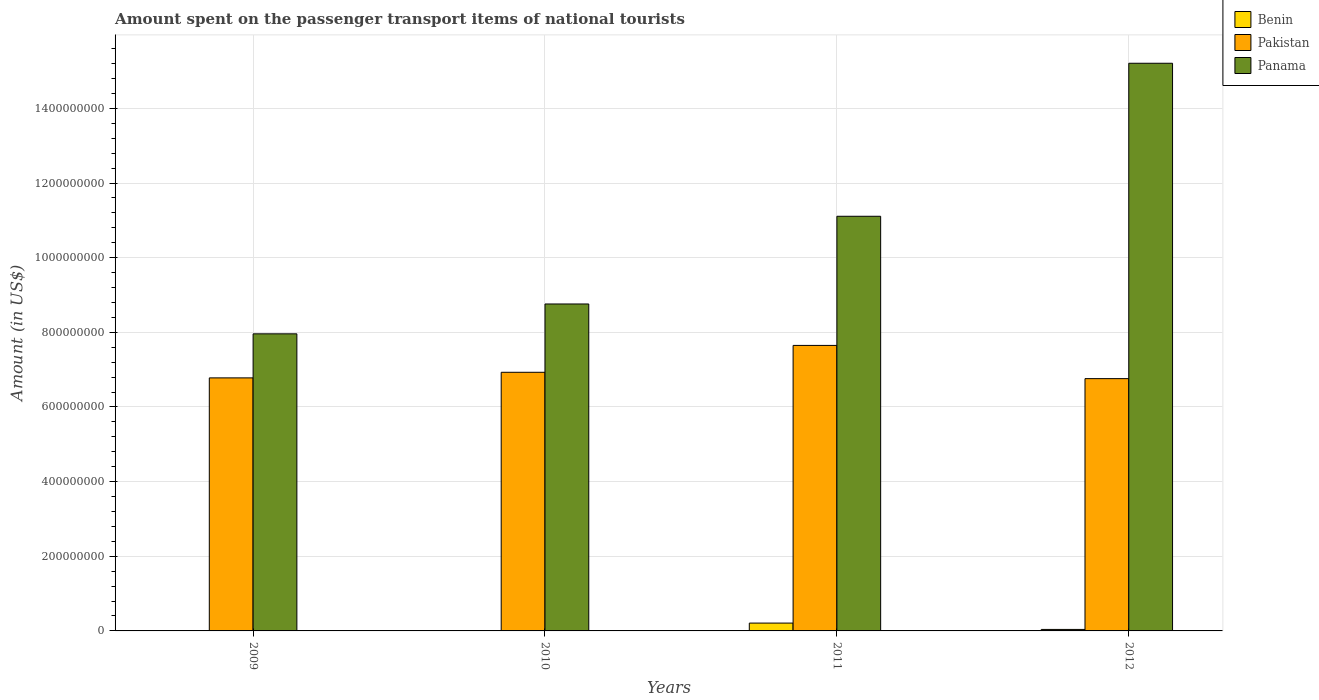How many groups of bars are there?
Ensure brevity in your answer.  4. Are the number of bars per tick equal to the number of legend labels?
Offer a terse response. Yes. Are the number of bars on each tick of the X-axis equal?
Your answer should be compact. Yes. How many bars are there on the 1st tick from the left?
Ensure brevity in your answer.  3. What is the amount spent on the passenger transport items of national tourists in Benin in 2010?
Ensure brevity in your answer.  4.00e+05. Across all years, what is the maximum amount spent on the passenger transport items of national tourists in Benin?
Your answer should be compact. 2.10e+07. Across all years, what is the minimum amount spent on the passenger transport items of national tourists in Benin?
Offer a very short reply. 4.00e+05. In which year was the amount spent on the passenger transport items of national tourists in Benin maximum?
Offer a terse response. 2011. What is the total amount spent on the passenger transport items of national tourists in Panama in the graph?
Give a very brief answer. 4.30e+09. What is the difference between the amount spent on the passenger transport items of national tourists in Panama in 2010 and that in 2011?
Make the answer very short. -2.35e+08. What is the difference between the amount spent on the passenger transport items of national tourists in Pakistan in 2011 and the amount spent on the passenger transport items of national tourists in Panama in 2012?
Keep it short and to the point. -7.56e+08. What is the average amount spent on the passenger transport items of national tourists in Panama per year?
Provide a short and direct response. 1.08e+09. In the year 2009, what is the difference between the amount spent on the passenger transport items of national tourists in Benin and amount spent on the passenger transport items of national tourists in Panama?
Ensure brevity in your answer.  -7.96e+08. In how many years, is the amount spent on the passenger transport items of national tourists in Benin greater than 560000000 US$?
Provide a succinct answer. 0. What is the ratio of the amount spent on the passenger transport items of national tourists in Pakistan in 2010 to that in 2011?
Give a very brief answer. 0.91. Is the amount spent on the passenger transport items of national tourists in Benin in 2009 less than that in 2012?
Your response must be concise. Yes. Is the difference between the amount spent on the passenger transport items of national tourists in Benin in 2010 and 2012 greater than the difference between the amount spent on the passenger transport items of national tourists in Panama in 2010 and 2012?
Give a very brief answer. Yes. What is the difference between the highest and the second highest amount spent on the passenger transport items of national tourists in Pakistan?
Your answer should be very brief. 7.20e+07. What is the difference between the highest and the lowest amount spent on the passenger transport items of national tourists in Panama?
Keep it short and to the point. 7.25e+08. In how many years, is the amount spent on the passenger transport items of national tourists in Benin greater than the average amount spent on the passenger transport items of national tourists in Benin taken over all years?
Give a very brief answer. 1. What does the 1st bar from the left in 2011 represents?
Give a very brief answer. Benin. What does the 2nd bar from the right in 2012 represents?
Keep it short and to the point. Pakistan. How many bars are there?
Your answer should be compact. 12. How many years are there in the graph?
Provide a succinct answer. 4. Does the graph contain any zero values?
Provide a short and direct response. No. Where does the legend appear in the graph?
Your answer should be compact. Top right. What is the title of the graph?
Make the answer very short. Amount spent on the passenger transport items of national tourists. What is the Amount (in US$) of Pakistan in 2009?
Your answer should be very brief. 6.78e+08. What is the Amount (in US$) of Panama in 2009?
Keep it short and to the point. 7.96e+08. What is the Amount (in US$) of Pakistan in 2010?
Provide a succinct answer. 6.93e+08. What is the Amount (in US$) of Panama in 2010?
Provide a succinct answer. 8.76e+08. What is the Amount (in US$) of Benin in 2011?
Your answer should be very brief. 2.10e+07. What is the Amount (in US$) in Pakistan in 2011?
Offer a very short reply. 7.65e+08. What is the Amount (in US$) in Panama in 2011?
Your response must be concise. 1.11e+09. What is the Amount (in US$) in Pakistan in 2012?
Your answer should be very brief. 6.76e+08. What is the Amount (in US$) in Panama in 2012?
Offer a terse response. 1.52e+09. Across all years, what is the maximum Amount (in US$) in Benin?
Give a very brief answer. 2.10e+07. Across all years, what is the maximum Amount (in US$) in Pakistan?
Keep it short and to the point. 7.65e+08. Across all years, what is the maximum Amount (in US$) of Panama?
Provide a succinct answer. 1.52e+09. Across all years, what is the minimum Amount (in US$) in Benin?
Keep it short and to the point. 4.00e+05. Across all years, what is the minimum Amount (in US$) of Pakistan?
Your answer should be very brief. 6.76e+08. Across all years, what is the minimum Amount (in US$) of Panama?
Your answer should be compact. 7.96e+08. What is the total Amount (in US$) of Benin in the graph?
Make the answer very short. 2.58e+07. What is the total Amount (in US$) of Pakistan in the graph?
Offer a very short reply. 2.81e+09. What is the total Amount (in US$) in Panama in the graph?
Provide a succinct answer. 4.30e+09. What is the difference between the Amount (in US$) in Pakistan in 2009 and that in 2010?
Ensure brevity in your answer.  -1.50e+07. What is the difference between the Amount (in US$) in Panama in 2009 and that in 2010?
Give a very brief answer. -8.00e+07. What is the difference between the Amount (in US$) of Benin in 2009 and that in 2011?
Keep it short and to the point. -2.06e+07. What is the difference between the Amount (in US$) of Pakistan in 2009 and that in 2011?
Keep it short and to the point. -8.70e+07. What is the difference between the Amount (in US$) of Panama in 2009 and that in 2011?
Provide a succinct answer. -3.15e+08. What is the difference between the Amount (in US$) in Benin in 2009 and that in 2012?
Provide a succinct answer. -3.60e+06. What is the difference between the Amount (in US$) of Pakistan in 2009 and that in 2012?
Your answer should be compact. 2.00e+06. What is the difference between the Amount (in US$) in Panama in 2009 and that in 2012?
Provide a succinct answer. -7.25e+08. What is the difference between the Amount (in US$) in Benin in 2010 and that in 2011?
Your answer should be compact. -2.06e+07. What is the difference between the Amount (in US$) of Pakistan in 2010 and that in 2011?
Make the answer very short. -7.20e+07. What is the difference between the Amount (in US$) of Panama in 2010 and that in 2011?
Offer a terse response. -2.35e+08. What is the difference between the Amount (in US$) in Benin in 2010 and that in 2012?
Give a very brief answer. -3.60e+06. What is the difference between the Amount (in US$) of Pakistan in 2010 and that in 2012?
Provide a short and direct response. 1.70e+07. What is the difference between the Amount (in US$) in Panama in 2010 and that in 2012?
Your answer should be compact. -6.45e+08. What is the difference between the Amount (in US$) in Benin in 2011 and that in 2012?
Your response must be concise. 1.70e+07. What is the difference between the Amount (in US$) in Pakistan in 2011 and that in 2012?
Offer a terse response. 8.90e+07. What is the difference between the Amount (in US$) of Panama in 2011 and that in 2012?
Ensure brevity in your answer.  -4.10e+08. What is the difference between the Amount (in US$) of Benin in 2009 and the Amount (in US$) of Pakistan in 2010?
Ensure brevity in your answer.  -6.93e+08. What is the difference between the Amount (in US$) in Benin in 2009 and the Amount (in US$) in Panama in 2010?
Keep it short and to the point. -8.76e+08. What is the difference between the Amount (in US$) in Pakistan in 2009 and the Amount (in US$) in Panama in 2010?
Provide a succinct answer. -1.98e+08. What is the difference between the Amount (in US$) in Benin in 2009 and the Amount (in US$) in Pakistan in 2011?
Provide a short and direct response. -7.65e+08. What is the difference between the Amount (in US$) of Benin in 2009 and the Amount (in US$) of Panama in 2011?
Provide a succinct answer. -1.11e+09. What is the difference between the Amount (in US$) of Pakistan in 2009 and the Amount (in US$) of Panama in 2011?
Your response must be concise. -4.33e+08. What is the difference between the Amount (in US$) in Benin in 2009 and the Amount (in US$) in Pakistan in 2012?
Offer a very short reply. -6.76e+08. What is the difference between the Amount (in US$) in Benin in 2009 and the Amount (in US$) in Panama in 2012?
Provide a succinct answer. -1.52e+09. What is the difference between the Amount (in US$) of Pakistan in 2009 and the Amount (in US$) of Panama in 2012?
Your answer should be compact. -8.43e+08. What is the difference between the Amount (in US$) in Benin in 2010 and the Amount (in US$) in Pakistan in 2011?
Your answer should be very brief. -7.65e+08. What is the difference between the Amount (in US$) of Benin in 2010 and the Amount (in US$) of Panama in 2011?
Your response must be concise. -1.11e+09. What is the difference between the Amount (in US$) in Pakistan in 2010 and the Amount (in US$) in Panama in 2011?
Keep it short and to the point. -4.18e+08. What is the difference between the Amount (in US$) of Benin in 2010 and the Amount (in US$) of Pakistan in 2012?
Offer a terse response. -6.76e+08. What is the difference between the Amount (in US$) in Benin in 2010 and the Amount (in US$) in Panama in 2012?
Keep it short and to the point. -1.52e+09. What is the difference between the Amount (in US$) in Pakistan in 2010 and the Amount (in US$) in Panama in 2012?
Give a very brief answer. -8.28e+08. What is the difference between the Amount (in US$) in Benin in 2011 and the Amount (in US$) in Pakistan in 2012?
Make the answer very short. -6.55e+08. What is the difference between the Amount (in US$) of Benin in 2011 and the Amount (in US$) of Panama in 2012?
Ensure brevity in your answer.  -1.50e+09. What is the difference between the Amount (in US$) in Pakistan in 2011 and the Amount (in US$) in Panama in 2012?
Keep it short and to the point. -7.56e+08. What is the average Amount (in US$) in Benin per year?
Give a very brief answer. 6.45e+06. What is the average Amount (in US$) of Pakistan per year?
Keep it short and to the point. 7.03e+08. What is the average Amount (in US$) of Panama per year?
Make the answer very short. 1.08e+09. In the year 2009, what is the difference between the Amount (in US$) of Benin and Amount (in US$) of Pakistan?
Provide a succinct answer. -6.78e+08. In the year 2009, what is the difference between the Amount (in US$) in Benin and Amount (in US$) in Panama?
Make the answer very short. -7.96e+08. In the year 2009, what is the difference between the Amount (in US$) in Pakistan and Amount (in US$) in Panama?
Make the answer very short. -1.18e+08. In the year 2010, what is the difference between the Amount (in US$) of Benin and Amount (in US$) of Pakistan?
Keep it short and to the point. -6.93e+08. In the year 2010, what is the difference between the Amount (in US$) of Benin and Amount (in US$) of Panama?
Your answer should be compact. -8.76e+08. In the year 2010, what is the difference between the Amount (in US$) in Pakistan and Amount (in US$) in Panama?
Give a very brief answer. -1.83e+08. In the year 2011, what is the difference between the Amount (in US$) in Benin and Amount (in US$) in Pakistan?
Provide a succinct answer. -7.44e+08. In the year 2011, what is the difference between the Amount (in US$) in Benin and Amount (in US$) in Panama?
Offer a terse response. -1.09e+09. In the year 2011, what is the difference between the Amount (in US$) of Pakistan and Amount (in US$) of Panama?
Your answer should be compact. -3.46e+08. In the year 2012, what is the difference between the Amount (in US$) in Benin and Amount (in US$) in Pakistan?
Your response must be concise. -6.72e+08. In the year 2012, what is the difference between the Amount (in US$) in Benin and Amount (in US$) in Panama?
Give a very brief answer. -1.52e+09. In the year 2012, what is the difference between the Amount (in US$) of Pakistan and Amount (in US$) of Panama?
Offer a terse response. -8.45e+08. What is the ratio of the Amount (in US$) in Benin in 2009 to that in 2010?
Offer a very short reply. 1. What is the ratio of the Amount (in US$) in Pakistan in 2009 to that in 2010?
Your answer should be very brief. 0.98. What is the ratio of the Amount (in US$) in Panama in 2009 to that in 2010?
Make the answer very short. 0.91. What is the ratio of the Amount (in US$) of Benin in 2009 to that in 2011?
Give a very brief answer. 0.02. What is the ratio of the Amount (in US$) in Pakistan in 2009 to that in 2011?
Provide a succinct answer. 0.89. What is the ratio of the Amount (in US$) in Panama in 2009 to that in 2011?
Offer a terse response. 0.72. What is the ratio of the Amount (in US$) in Benin in 2009 to that in 2012?
Keep it short and to the point. 0.1. What is the ratio of the Amount (in US$) of Pakistan in 2009 to that in 2012?
Your response must be concise. 1. What is the ratio of the Amount (in US$) of Panama in 2009 to that in 2012?
Offer a terse response. 0.52. What is the ratio of the Amount (in US$) of Benin in 2010 to that in 2011?
Provide a succinct answer. 0.02. What is the ratio of the Amount (in US$) in Pakistan in 2010 to that in 2011?
Provide a succinct answer. 0.91. What is the ratio of the Amount (in US$) in Panama in 2010 to that in 2011?
Provide a short and direct response. 0.79. What is the ratio of the Amount (in US$) of Pakistan in 2010 to that in 2012?
Make the answer very short. 1.03. What is the ratio of the Amount (in US$) in Panama in 2010 to that in 2012?
Provide a succinct answer. 0.58. What is the ratio of the Amount (in US$) in Benin in 2011 to that in 2012?
Your answer should be compact. 5.25. What is the ratio of the Amount (in US$) in Pakistan in 2011 to that in 2012?
Provide a short and direct response. 1.13. What is the ratio of the Amount (in US$) of Panama in 2011 to that in 2012?
Provide a short and direct response. 0.73. What is the difference between the highest and the second highest Amount (in US$) of Benin?
Make the answer very short. 1.70e+07. What is the difference between the highest and the second highest Amount (in US$) in Pakistan?
Offer a very short reply. 7.20e+07. What is the difference between the highest and the second highest Amount (in US$) in Panama?
Make the answer very short. 4.10e+08. What is the difference between the highest and the lowest Amount (in US$) in Benin?
Give a very brief answer. 2.06e+07. What is the difference between the highest and the lowest Amount (in US$) of Pakistan?
Give a very brief answer. 8.90e+07. What is the difference between the highest and the lowest Amount (in US$) of Panama?
Ensure brevity in your answer.  7.25e+08. 